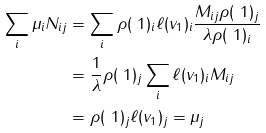<formula> <loc_0><loc_0><loc_500><loc_500>\sum _ { i } \mu _ { i } N _ { i j } & = \sum _ { i } \rho ( \ 1 ) _ { i } \ell ( v _ { 1 } ) _ { i } \frac { M _ { i j } \rho ( \ 1 ) _ { j } } { \lambda \rho ( \ 1 ) _ { i } } \\ & = \frac { 1 } { \lambda } \rho ( \ 1 ) _ { j } \sum _ { i } \ell ( v _ { 1 } ) _ { i } M _ { i j } \\ & = \rho ( \ 1 ) _ { j } \ell ( v _ { 1 } ) _ { j } = \mu _ { j }</formula> 